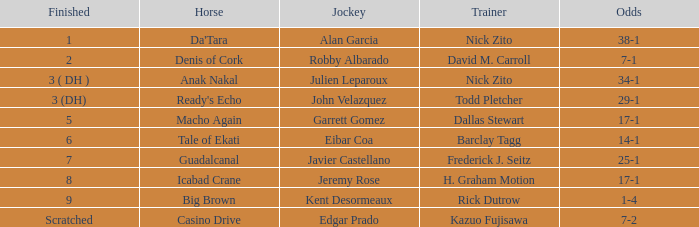Which Horse finished in 8? Icabad Crane. 